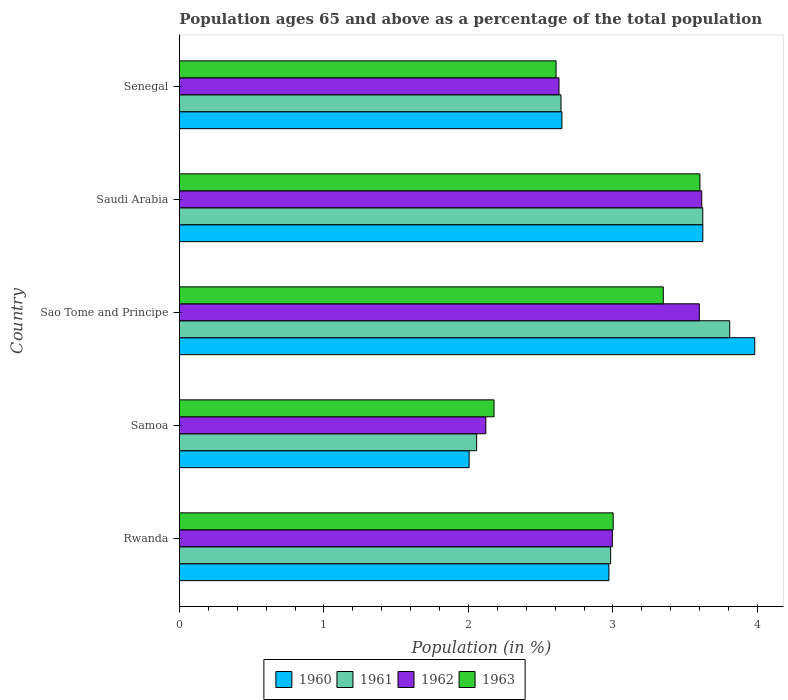Are the number of bars per tick equal to the number of legend labels?
Your response must be concise. Yes. Are the number of bars on each tick of the Y-axis equal?
Give a very brief answer. Yes. How many bars are there on the 2nd tick from the bottom?
Make the answer very short. 4. What is the label of the 5th group of bars from the top?
Give a very brief answer. Rwanda. What is the percentage of the population ages 65 and above in 1960 in Saudi Arabia?
Make the answer very short. 3.62. Across all countries, what is the maximum percentage of the population ages 65 and above in 1963?
Offer a very short reply. 3.6. Across all countries, what is the minimum percentage of the population ages 65 and above in 1963?
Keep it short and to the point. 2.18. In which country was the percentage of the population ages 65 and above in 1962 maximum?
Ensure brevity in your answer.  Saudi Arabia. In which country was the percentage of the population ages 65 and above in 1963 minimum?
Keep it short and to the point. Samoa. What is the total percentage of the population ages 65 and above in 1960 in the graph?
Your response must be concise. 15.23. What is the difference between the percentage of the population ages 65 and above in 1962 in Rwanda and that in Saudi Arabia?
Keep it short and to the point. -0.62. What is the difference between the percentage of the population ages 65 and above in 1961 in Sao Tome and Principe and the percentage of the population ages 65 and above in 1963 in Samoa?
Ensure brevity in your answer.  1.63. What is the average percentage of the population ages 65 and above in 1960 per country?
Make the answer very short. 3.05. What is the difference between the percentage of the population ages 65 and above in 1961 and percentage of the population ages 65 and above in 1963 in Rwanda?
Offer a very short reply. -0.02. What is the ratio of the percentage of the population ages 65 and above in 1962 in Sao Tome and Principe to that in Senegal?
Your response must be concise. 1.37. Is the difference between the percentage of the population ages 65 and above in 1961 in Sao Tome and Principe and Saudi Arabia greater than the difference between the percentage of the population ages 65 and above in 1963 in Sao Tome and Principe and Saudi Arabia?
Provide a succinct answer. Yes. What is the difference between the highest and the second highest percentage of the population ages 65 and above in 1963?
Your answer should be compact. 0.25. What is the difference between the highest and the lowest percentage of the population ages 65 and above in 1961?
Offer a terse response. 1.75. Is it the case that in every country, the sum of the percentage of the population ages 65 and above in 1963 and percentage of the population ages 65 and above in 1961 is greater than the sum of percentage of the population ages 65 and above in 1960 and percentage of the population ages 65 and above in 1962?
Offer a terse response. No. What does the 1st bar from the top in Saudi Arabia represents?
Your response must be concise. 1963. What does the 4th bar from the bottom in Samoa represents?
Your response must be concise. 1963. How many bars are there?
Ensure brevity in your answer.  20. Are the values on the major ticks of X-axis written in scientific E-notation?
Give a very brief answer. No. Does the graph contain any zero values?
Make the answer very short. No. How are the legend labels stacked?
Offer a very short reply. Horizontal. What is the title of the graph?
Your response must be concise. Population ages 65 and above as a percentage of the total population. Does "1967" appear as one of the legend labels in the graph?
Give a very brief answer. No. What is the label or title of the Y-axis?
Offer a terse response. Country. What is the Population (in %) in 1960 in Rwanda?
Make the answer very short. 2.97. What is the Population (in %) of 1961 in Rwanda?
Make the answer very short. 2.98. What is the Population (in %) in 1962 in Rwanda?
Your answer should be very brief. 3. What is the Population (in %) of 1963 in Rwanda?
Provide a short and direct response. 3. What is the Population (in %) in 1960 in Samoa?
Your response must be concise. 2. What is the Population (in %) in 1961 in Samoa?
Provide a short and direct response. 2.06. What is the Population (in %) of 1962 in Samoa?
Provide a short and direct response. 2.12. What is the Population (in %) in 1963 in Samoa?
Offer a very short reply. 2.18. What is the Population (in %) of 1960 in Sao Tome and Principe?
Give a very brief answer. 3.98. What is the Population (in %) of 1961 in Sao Tome and Principe?
Make the answer very short. 3.81. What is the Population (in %) in 1962 in Sao Tome and Principe?
Provide a short and direct response. 3.6. What is the Population (in %) of 1963 in Sao Tome and Principe?
Provide a short and direct response. 3.35. What is the Population (in %) of 1960 in Saudi Arabia?
Your answer should be very brief. 3.62. What is the Population (in %) in 1961 in Saudi Arabia?
Your answer should be very brief. 3.62. What is the Population (in %) in 1962 in Saudi Arabia?
Provide a short and direct response. 3.61. What is the Population (in %) in 1963 in Saudi Arabia?
Your answer should be very brief. 3.6. What is the Population (in %) in 1960 in Senegal?
Your answer should be compact. 2.65. What is the Population (in %) of 1961 in Senegal?
Your answer should be compact. 2.64. What is the Population (in %) in 1962 in Senegal?
Give a very brief answer. 2.63. What is the Population (in %) of 1963 in Senegal?
Give a very brief answer. 2.61. Across all countries, what is the maximum Population (in %) of 1960?
Offer a very short reply. 3.98. Across all countries, what is the maximum Population (in %) of 1961?
Your response must be concise. 3.81. Across all countries, what is the maximum Population (in %) of 1962?
Your answer should be compact. 3.61. Across all countries, what is the maximum Population (in %) in 1963?
Offer a terse response. 3.6. Across all countries, what is the minimum Population (in %) of 1960?
Ensure brevity in your answer.  2. Across all countries, what is the minimum Population (in %) in 1961?
Give a very brief answer. 2.06. Across all countries, what is the minimum Population (in %) in 1962?
Offer a very short reply. 2.12. Across all countries, what is the minimum Population (in %) in 1963?
Give a very brief answer. 2.18. What is the total Population (in %) of 1960 in the graph?
Your answer should be very brief. 15.23. What is the total Population (in %) in 1961 in the graph?
Provide a succinct answer. 15.11. What is the total Population (in %) of 1962 in the graph?
Your response must be concise. 14.95. What is the total Population (in %) of 1963 in the graph?
Give a very brief answer. 14.74. What is the difference between the Population (in %) in 1960 in Rwanda and that in Samoa?
Your response must be concise. 0.97. What is the difference between the Population (in %) of 1961 in Rwanda and that in Samoa?
Offer a very short reply. 0.93. What is the difference between the Population (in %) of 1962 in Rwanda and that in Samoa?
Provide a short and direct response. 0.88. What is the difference between the Population (in %) of 1963 in Rwanda and that in Samoa?
Provide a short and direct response. 0.82. What is the difference between the Population (in %) in 1960 in Rwanda and that in Sao Tome and Principe?
Your answer should be very brief. -1.01. What is the difference between the Population (in %) in 1961 in Rwanda and that in Sao Tome and Principe?
Your answer should be compact. -0.82. What is the difference between the Population (in %) in 1962 in Rwanda and that in Sao Tome and Principe?
Keep it short and to the point. -0.6. What is the difference between the Population (in %) of 1963 in Rwanda and that in Sao Tome and Principe?
Ensure brevity in your answer.  -0.35. What is the difference between the Population (in %) in 1960 in Rwanda and that in Saudi Arabia?
Ensure brevity in your answer.  -0.65. What is the difference between the Population (in %) of 1961 in Rwanda and that in Saudi Arabia?
Make the answer very short. -0.64. What is the difference between the Population (in %) in 1962 in Rwanda and that in Saudi Arabia?
Your answer should be compact. -0.62. What is the difference between the Population (in %) in 1963 in Rwanda and that in Saudi Arabia?
Offer a terse response. -0.6. What is the difference between the Population (in %) in 1960 in Rwanda and that in Senegal?
Make the answer very short. 0.33. What is the difference between the Population (in %) of 1961 in Rwanda and that in Senegal?
Make the answer very short. 0.34. What is the difference between the Population (in %) in 1962 in Rwanda and that in Senegal?
Provide a succinct answer. 0.37. What is the difference between the Population (in %) in 1963 in Rwanda and that in Senegal?
Provide a succinct answer. 0.4. What is the difference between the Population (in %) in 1960 in Samoa and that in Sao Tome and Principe?
Give a very brief answer. -1.98. What is the difference between the Population (in %) in 1961 in Samoa and that in Sao Tome and Principe?
Ensure brevity in your answer.  -1.75. What is the difference between the Population (in %) of 1962 in Samoa and that in Sao Tome and Principe?
Provide a succinct answer. -1.48. What is the difference between the Population (in %) of 1963 in Samoa and that in Sao Tome and Principe?
Provide a succinct answer. -1.17. What is the difference between the Population (in %) in 1960 in Samoa and that in Saudi Arabia?
Ensure brevity in your answer.  -1.62. What is the difference between the Population (in %) in 1961 in Samoa and that in Saudi Arabia?
Ensure brevity in your answer.  -1.56. What is the difference between the Population (in %) in 1962 in Samoa and that in Saudi Arabia?
Offer a terse response. -1.49. What is the difference between the Population (in %) in 1963 in Samoa and that in Saudi Arabia?
Ensure brevity in your answer.  -1.42. What is the difference between the Population (in %) of 1960 in Samoa and that in Senegal?
Offer a terse response. -0.64. What is the difference between the Population (in %) in 1961 in Samoa and that in Senegal?
Give a very brief answer. -0.58. What is the difference between the Population (in %) of 1962 in Samoa and that in Senegal?
Offer a terse response. -0.51. What is the difference between the Population (in %) in 1963 in Samoa and that in Senegal?
Offer a terse response. -0.43. What is the difference between the Population (in %) in 1960 in Sao Tome and Principe and that in Saudi Arabia?
Ensure brevity in your answer.  0.36. What is the difference between the Population (in %) of 1961 in Sao Tome and Principe and that in Saudi Arabia?
Provide a succinct answer. 0.19. What is the difference between the Population (in %) of 1962 in Sao Tome and Principe and that in Saudi Arabia?
Your answer should be compact. -0.02. What is the difference between the Population (in %) of 1963 in Sao Tome and Principe and that in Saudi Arabia?
Offer a terse response. -0.25. What is the difference between the Population (in %) in 1960 in Sao Tome and Principe and that in Senegal?
Make the answer very short. 1.33. What is the difference between the Population (in %) in 1961 in Sao Tome and Principe and that in Senegal?
Provide a short and direct response. 1.17. What is the difference between the Population (in %) of 1962 in Sao Tome and Principe and that in Senegal?
Give a very brief answer. 0.97. What is the difference between the Population (in %) of 1963 in Sao Tome and Principe and that in Senegal?
Ensure brevity in your answer.  0.74. What is the difference between the Population (in %) of 1960 in Saudi Arabia and that in Senegal?
Keep it short and to the point. 0.97. What is the difference between the Population (in %) in 1963 in Saudi Arabia and that in Senegal?
Give a very brief answer. 1. What is the difference between the Population (in %) of 1960 in Rwanda and the Population (in %) of 1961 in Samoa?
Make the answer very short. 0.92. What is the difference between the Population (in %) in 1960 in Rwanda and the Population (in %) in 1962 in Samoa?
Offer a very short reply. 0.85. What is the difference between the Population (in %) in 1960 in Rwanda and the Population (in %) in 1963 in Samoa?
Your answer should be very brief. 0.79. What is the difference between the Population (in %) of 1961 in Rwanda and the Population (in %) of 1962 in Samoa?
Offer a terse response. 0.86. What is the difference between the Population (in %) in 1961 in Rwanda and the Population (in %) in 1963 in Samoa?
Keep it short and to the point. 0.81. What is the difference between the Population (in %) of 1962 in Rwanda and the Population (in %) of 1963 in Samoa?
Ensure brevity in your answer.  0.82. What is the difference between the Population (in %) of 1960 in Rwanda and the Population (in %) of 1961 in Sao Tome and Principe?
Make the answer very short. -0.84. What is the difference between the Population (in %) of 1960 in Rwanda and the Population (in %) of 1962 in Sao Tome and Principe?
Offer a terse response. -0.63. What is the difference between the Population (in %) of 1960 in Rwanda and the Population (in %) of 1963 in Sao Tome and Principe?
Ensure brevity in your answer.  -0.38. What is the difference between the Population (in %) of 1961 in Rwanda and the Population (in %) of 1962 in Sao Tome and Principe?
Offer a very short reply. -0.61. What is the difference between the Population (in %) of 1961 in Rwanda and the Population (in %) of 1963 in Sao Tome and Principe?
Keep it short and to the point. -0.36. What is the difference between the Population (in %) in 1962 in Rwanda and the Population (in %) in 1963 in Sao Tome and Principe?
Ensure brevity in your answer.  -0.35. What is the difference between the Population (in %) of 1960 in Rwanda and the Population (in %) of 1961 in Saudi Arabia?
Ensure brevity in your answer.  -0.65. What is the difference between the Population (in %) of 1960 in Rwanda and the Population (in %) of 1962 in Saudi Arabia?
Your answer should be very brief. -0.64. What is the difference between the Population (in %) in 1960 in Rwanda and the Population (in %) in 1963 in Saudi Arabia?
Ensure brevity in your answer.  -0.63. What is the difference between the Population (in %) of 1961 in Rwanda and the Population (in %) of 1962 in Saudi Arabia?
Offer a very short reply. -0.63. What is the difference between the Population (in %) of 1961 in Rwanda and the Population (in %) of 1963 in Saudi Arabia?
Your answer should be very brief. -0.62. What is the difference between the Population (in %) in 1962 in Rwanda and the Population (in %) in 1963 in Saudi Arabia?
Keep it short and to the point. -0.61. What is the difference between the Population (in %) of 1960 in Rwanda and the Population (in %) of 1961 in Senegal?
Make the answer very short. 0.33. What is the difference between the Population (in %) of 1960 in Rwanda and the Population (in %) of 1962 in Senegal?
Your answer should be compact. 0.35. What is the difference between the Population (in %) in 1960 in Rwanda and the Population (in %) in 1963 in Senegal?
Your response must be concise. 0.37. What is the difference between the Population (in %) of 1961 in Rwanda and the Population (in %) of 1962 in Senegal?
Give a very brief answer. 0.36. What is the difference between the Population (in %) in 1961 in Rwanda and the Population (in %) in 1963 in Senegal?
Provide a succinct answer. 0.38. What is the difference between the Population (in %) of 1962 in Rwanda and the Population (in %) of 1963 in Senegal?
Offer a very short reply. 0.39. What is the difference between the Population (in %) in 1960 in Samoa and the Population (in %) in 1961 in Sao Tome and Principe?
Keep it short and to the point. -1.8. What is the difference between the Population (in %) in 1960 in Samoa and the Population (in %) in 1962 in Sao Tome and Principe?
Ensure brevity in your answer.  -1.59. What is the difference between the Population (in %) of 1960 in Samoa and the Population (in %) of 1963 in Sao Tome and Principe?
Give a very brief answer. -1.34. What is the difference between the Population (in %) of 1961 in Samoa and the Population (in %) of 1962 in Sao Tome and Principe?
Ensure brevity in your answer.  -1.54. What is the difference between the Population (in %) of 1961 in Samoa and the Population (in %) of 1963 in Sao Tome and Principe?
Keep it short and to the point. -1.29. What is the difference between the Population (in %) of 1962 in Samoa and the Population (in %) of 1963 in Sao Tome and Principe?
Make the answer very short. -1.23. What is the difference between the Population (in %) in 1960 in Samoa and the Population (in %) in 1961 in Saudi Arabia?
Your response must be concise. -1.62. What is the difference between the Population (in %) of 1960 in Samoa and the Population (in %) of 1962 in Saudi Arabia?
Keep it short and to the point. -1.61. What is the difference between the Population (in %) in 1960 in Samoa and the Population (in %) in 1963 in Saudi Arabia?
Keep it short and to the point. -1.6. What is the difference between the Population (in %) of 1961 in Samoa and the Population (in %) of 1962 in Saudi Arabia?
Offer a very short reply. -1.56. What is the difference between the Population (in %) of 1961 in Samoa and the Population (in %) of 1963 in Saudi Arabia?
Offer a very short reply. -1.55. What is the difference between the Population (in %) in 1962 in Samoa and the Population (in %) in 1963 in Saudi Arabia?
Your response must be concise. -1.48. What is the difference between the Population (in %) in 1960 in Samoa and the Population (in %) in 1961 in Senegal?
Ensure brevity in your answer.  -0.64. What is the difference between the Population (in %) of 1960 in Samoa and the Population (in %) of 1962 in Senegal?
Keep it short and to the point. -0.62. What is the difference between the Population (in %) of 1960 in Samoa and the Population (in %) of 1963 in Senegal?
Provide a short and direct response. -0.6. What is the difference between the Population (in %) in 1961 in Samoa and the Population (in %) in 1962 in Senegal?
Keep it short and to the point. -0.57. What is the difference between the Population (in %) of 1961 in Samoa and the Population (in %) of 1963 in Senegal?
Keep it short and to the point. -0.55. What is the difference between the Population (in %) of 1962 in Samoa and the Population (in %) of 1963 in Senegal?
Make the answer very short. -0.49. What is the difference between the Population (in %) in 1960 in Sao Tome and Principe and the Population (in %) in 1961 in Saudi Arabia?
Your response must be concise. 0.36. What is the difference between the Population (in %) of 1960 in Sao Tome and Principe and the Population (in %) of 1962 in Saudi Arabia?
Provide a short and direct response. 0.37. What is the difference between the Population (in %) in 1960 in Sao Tome and Principe and the Population (in %) in 1963 in Saudi Arabia?
Your answer should be very brief. 0.38. What is the difference between the Population (in %) in 1961 in Sao Tome and Principe and the Population (in %) in 1962 in Saudi Arabia?
Provide a short and direct response. 0.19. What is the difference between the Population (in %) of 1961 in Sao Tome and Principe and the Population (in %) of 1963 in Saudi Arabia?
Provide a succinct answer. 0.21. What is the difference between the Population (in %) of 1962 in Sao Tome and Principe and the Population (in %) of 1963 in Saudi Arabia?
Provide a succinct answer. -0. What is the difference between the Population (in %) in 1960 in Sao Tome and Principe and the Population (in %) in 1961 in Senegal?
Your answer should be compact. 1.34. What is the difference between the Population (in %) in 1960 in Sao Tome and Principe and the Population (in %) in 1962 in Senegal?
Your response must be concise. 1.35. What is the difference between the Population (in %) in 1960 in Sao Tome and Principe and the Population (in %) in 1963 in Senegal?
Your answer should be compact. 1.37. What is the difference between the Population (in %) of 1961 in Sao Tome and Principe and the Population (in %) of 1962 in Senegal?
Ensure brevity in your answer.  1.18. What is the difference between the Population (in %) of 1961 in Sao Tome and Principe and the Population (in %) of 1963 in Senegal?
Keep it short and to the point. 1.2. What is the difference between the Population (in %) in 1960 in Saudi Arabia and the Population (in %) in 1961 in Senegal?
Offer a terse response. 0.98. What is the difference between the Population (in %) in 1960 in Saudi Arabia and the Population (in %) in 1962 in Senegal?
Ensure brevity in your answer.  1. What is the difference between the Population (in %) of 1960 in Saudi Arabia and the Population (in %) of 1963 in Senegal?
Offer a very short reply. 1.02. What is the difference between the Population (in %) in 1961 in Saudi Arabia and the Population (in %) in 1962 in Senegal?
Give a very brief answer. 0.99. What is the difference between the Population (in %) in 1961 in Saudi Arabia and the Population (in %) in 1963 in Senegal?
Offer a terse response. 1.02. What is the average Population (in %) of 1960 per country?
Provide a short and direct response. 3.05. What is the average Population (in %) of 1961 per country?
Ensure brevity in your answer.  3.02. What is the average Population (in %) of 1962 per country?
Keep it short and to the point. 2.99. What is the average Population (in %) in 1963 per country?
Offer a terse response. 2.95. What is the difference between the Population (in %) in 1960 and Population (in %) in 1961 in Rwanda?
Offer a very short reply. -0.01. What is the difference between the Population (in %) in 1960 and Population (in %) in 1962 in Rwanda?
Keep it short and to the point. -0.02. What is the difference between the Population (in %) of 1960 and Population (in %) of 1963 in Rwanda?
Your answer should be very brief. -0.03. What is the difference between the Population (in %) of 1961 and Population (in %) of 1962 in Rwanda?
Make the answer very short. -0.01. What is the difference between the Population (in %) of 1961 and Population (in %) of 1963 in Rwanda?
Offer a very short reply. -0.02. What is the difference between the Population (in %) of 1962 and Population (in %) of 1963 in Rwanda?
Ensure brevity in your answer.  -0.01. What is the difference between the Population (in %) in 1960 and Population (in %) in 1961 in Samoa?
Give a very brief answer. -0.05. What is the difference between the Population (in %) of 1960 and Population (in %) of 1962 in Samoa?
Provide a succinct answer. -0.12. What is the difference between the Population (in %) in 1960 and Population (in %) in 1963 in Samoa?
Give a very brief answer. -0.17. What is the difference between the Population (in %) in 1961 and Population (in %) in 1962 in Samoa?
Make the answer very short. -0.06. What is the difference between the Population (in %) of 1961 and Population (in %) of 1963 in Samoa?
Ensure brevity in your answer.  -0.12. What is the difference between the Population (in %) in 1962 and Population (in %) in 1963 in Samoa?
Your response must be concise. -0.06. What is the difference between the Population (in %) in 1960 and Population (in %) in 1961 in Sao Tome and Principe?
Keep it short and to the point. 0.17. What is the difference between the Population (in %) of 1960 and Population (in %) of 1962 in Sao Tome and Principe?
Ensure brevity in your answer.  0.38. What is the difference between the Population (in %) of 1960 and Population (in %) of 1963 in Sao Tome and Principe?
Ensure brevity in your answer.  0.63. What is the difference between the Population (in %) of 1961 and Population (in %) of 1962 in Sao Tome and Principe?
Your answer should be very brief. 0.21. What is the difference between the Population (in %) of 1961 and Population (in %) of 1963 in Sao Tome and Principe?
Keep it short and to the point. 0.46. What is the difference between the Population (in %) of 1962 and Population (in %) of 1963 in Sao Tome and Principe?
Your response must be concise. 0.25. What is the difference between the Population (in %) of 1960 and Population (in %) of 1962 in Saudi Arabia?
Your response must be concise. 0.01. What is the difference between the Population (in %) of 1960 and Population (in %) of 1963 in Saudi Arabia?
Ensure brevity in your answer.  0.02. What is the difference between the Population (in %) of 1961 and Population (in %) of 1962 in Saudi Arabia?
Provide a short and direct response. 0.01. What is the difference between the Population (in %) of 1961 and Population (in %) of 1963 in Saudi Arabia?
Keep it short and to the point. 0.02. What is the difference between the Population (in %) of 1962 and Population (in %) of 1963 in Saudi Arabia?
Provide a succinct answer. 0.01. What is the difference between the Population (in %) in 1960 and Population (in %) in 1961 in Senegal?
Provide a succinct answer. 0.01. What is the difference between the Population (in %) in 1960 and Population (in %) in 1962 in Senegal?
Give a very brief answer. 0.02. What is the difference between the Population (in %) of 1960 and Population (in %) of 1963 in Senegal?
Ensure brevity in your answer.  0.04. What is the difference between the Population (in %) in 1961 and Population (in %) in 1962 in Senegal?
Give a very brief answer. 0.01. What is the difference between the Population (in %) of 1961 and Population (in %) of 1963 in Senegal?
Offer a very short reply. 0.03. What is the difference between the Population (in %) of 1962 and Population (in %) of 1963 in Senegal?
Give a very brief answer. 0.02. What is the ratio of the Population (in %) of 1960 in Rwanda to that in Samoa?
Your answer should be very brief. 1.48. What is the ratio of the Population (in %) in 1961 in Rwanda to that in Samoa?
Make the answer very short. 1.45. What is the ratio of the Population (in %) of 1962 in Rwanda to that in Samoa?
Offer a very short reply. 1.41. What is the ratio of the Population (in %) of 1963 in Rwanda to that in Samoa?
Your answer should be compact. 1.38. What is the ratio of the Population (in %) in 1960 in Rwanda to that in Sao Tome and Principe?
Keep it short and to the point. 0.75. What is the ratio of the Population (in %) in 1961 in Rwanda to that in Sao Tome and Principe?
Offer a terse response. 0.78. What is the ratio of the Population (in %) of 1962 in Rwanda to that in Sao Tome and Principe?
Provide a short and direct response. 0.83. What is the ratio of the Population (in %) in 1963 in Rwanda to that in Sao Tome and Principe?
Offer a very short reply. 0.9. What is the ratio of the Population (in %) of 1960 in Rwanda to that in Saudi Arabia?
Provide a succinct answer. 0.82. What is the ratio of the Population (in %) of 1961 in Rwanda to that in Saudi Arabia?
Your response must be concise. 0.82. What is the ratio of the Population (in %) in 1962 in Rwanda to that in Saudi Arabia?
Offer a very short reply. 0.83. What is the ratio of the Population (in %) in 1963 in Rwanda to that in Saudi Arabia?
Provide a short and direct response. 0.83. What is the ratio of the Population (in %) of 1960 in Rwanda to that in Senegal?
Give a very brief answer. 1.12. What is the ratio of the Population (in %) of 1961 in Rwanda to that in Senegal?
Offer a terse response. 1.13. What is the ratio of the Population (in %) of 1962 in Rwanda to that in Senegal?
Offer a terse response. 1.14. What is the ratio of the Population (in %) in 1963 in Rwanda to that in Senegal?
Give a very brief answer. 1.15. What is the ratio of the Population (in %) of 1960 in Samoa to that in Sao Tome and Principe?
Your response must be concise. 0.5. What is the ratio of the Population (in %) in 1961 in Samoa to that in Sao Tome and Principe?
Offer a very short reply. 0.54. What is the ratio of the Population (in %) in 1962 in Samoa to that in Sao Tome and Principe?
Give a very brief answer. 0.59. What is the ratio of the Population (in %) in 1963 in Samoa to that in Sao Tome and Principe?
Your answer should be very brief. 0.65. What is the ratio of the Population (in %) of 1960 in Samoa to that in Saudi Arabia?
Provide a short and direct response. 0.55. What is the ratio of the Population (in %) in 1961 in Samoa to that in Saudi Arabia?
Offer a very short reply. 0.57. What is the ratio of the Population (in %) in 1962 in Samoa to that in Saudi Arabia?
Your answer should be very brief. 0.59. What is the ratio of the Population (in %) in 1963 in Samoa to that in Saudi Arabia?
Your response must be concise. 0.6. What is the ratio of the Population (in %) in 1960 in Samoa to that in Senegal?
Give a very brief answer. 0.76. What is the ratio of the Population (in %) in 1961 in Samoa to that in Senegal?
Offer a very short reply. 0.78. What is the ratio of the Population (in %) of 1962 in Samoa to that in Senegal?
Ensure brevity in your answer.  0.81. What is the ratio of the Population (in %) in 1963 in Samoa to that in Senegal?
Your response must be concise. 0.84. What is the ratio of the Population (in %) in 1960 in Sao Tome and Principe to that in Saudi Arabia?
Make the answer very short. 1.1. What is the ratio of the Population (in %) of 1961 in Sao Tome and Principe to that in Saudi Arabia?
Provide a succinct answer. 1.05. What is the ratio of the Population (in %) of 1963 in Sao Tome and Principe to that in Saudi Arabia?
Offer a very short reply. 0.93. What is the ratio of the Population (in %) in 1960 in Sao Tome and Principe to that in Senegal?
Provide a succinct answer. 1.5. What is the ratio of the Population (in %) in 1961 in Sao Tome and Principe to that in Senegal?
Your response must be concise. 1.44. What is the ratio of the Population (in %) in 1962 in Sao Tome and Principe to that in Senegal?
Give a very brief answer. 1.37. What is the ratio of the Population (in %) in 1963 in Sao Tome and Principe to that in Senegal?
Ensure brevity in your answer.  1.28. What is the ratio of the Population (in %) of 1960 in Saudi Arabia to that in Senegal?
Provide a succinct answer. 1.37. What is the ratio of the Population (in %) of 1961 in Saudi Arabia to that in Senegal?
Offer a terse response. 1.37. What is the ratio of the Population (in %) of 1962 in Saudi Arabia to that in Senegal?
Your answer should be very brief. 1.38. What is the ratio of the Population (in %) in 1963 in Saudi Arabia to that in Senegal?
Your answer should be very brief. 1.38. What is the difference between the highest and the second highest Population (in %) in 1960?
Give a very brief answer. 0.36. What is the difference between the highest and the second highest Population (in %) of 1961?
Give a very brief answer. 0.19. What is the difference between the highest and the second highest Population (in %) of 1962?
Offer a very short reply. 0.02. What is the difference between the highest and the second highest Population (in %) in 1963?
Your answer should be very brief. 0.25. What is the difference between the highest and the lowest Population (in %) of 1960?
Offer a very short reply. 1.98. What is the difference between the highest and the lowest Population (in %) in 1961?
Offer a very short reply. 1.75. What is the difference between the highest and the lowest Population (in %) in 1962?
Offer a very short reply. 1.49. What is the difference between the highest and the lowest Population (in %) in 1963?
Your answer should be compact. 1.42. 